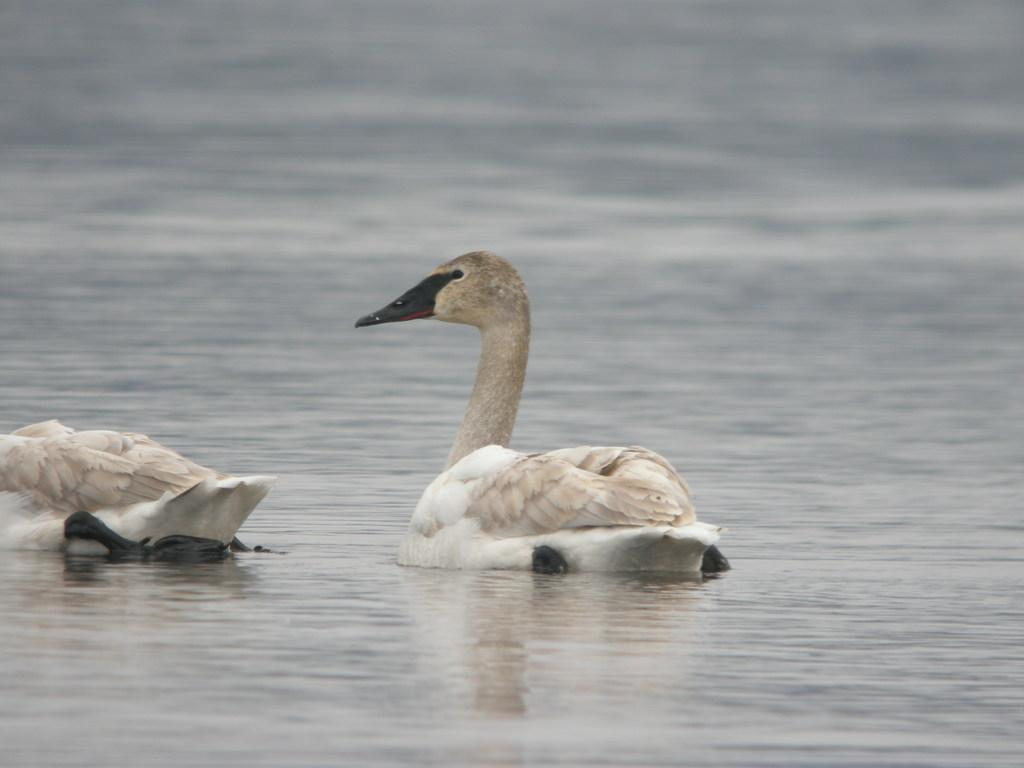What colors can be seen on the ducks in the image? The ducks in the image have brown and white colors. What feature do the ducks have on their faces? The ducks have black beaks. What are the ducks doing in the image? The ducks are paddling in the river. What type of stomach can be seen in the image? There is no stomach visible in the image. 